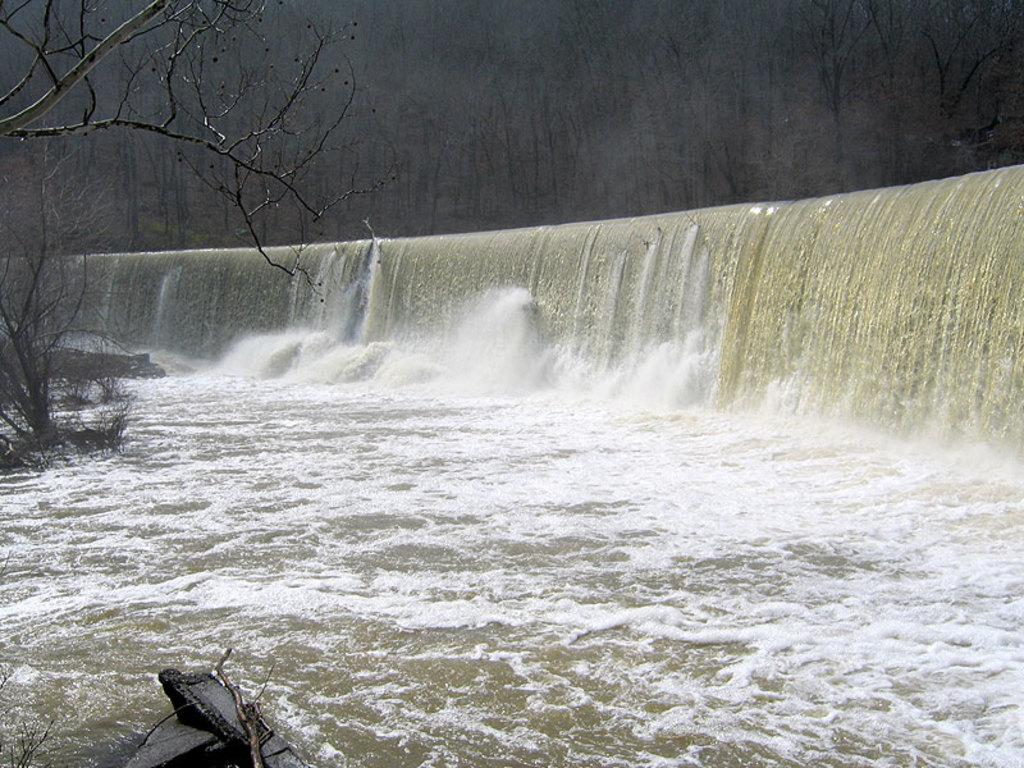What natural feature is the main subject of the image? There is a waterfall in the image. What type of vegetation can be seen in the image? There are trees in the image. What type of appliance can be seen near the waterfall in the image? There is no appliance present near the waterfall in the image. What type of leather material can be seen on the trees in the image? There is no leather material present on the trees in the image; they are natural vegetation. 